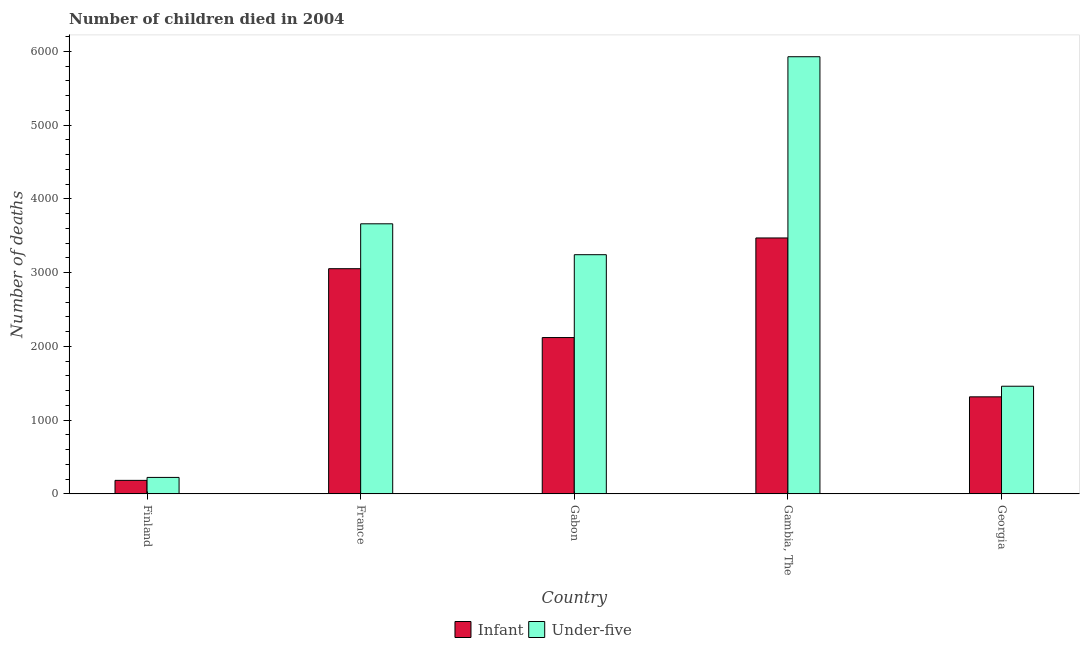How many groups of bars are there?
Provide a succinct answer. 5. Are the number of bars on each tick of the X-axis equal?
Make the answer very short. Yes. How many bars are there on the 2nd tick from the right?
Give a very brief answer. 2. What is the label of the 4th group of bars from the left?
Offer a very short reply. Gambia, The. What is the number of under-five deaths in Georgia?
Ensure brevity in your answer.  1460. Across all countries, what is the maximum number of under-five deaths?
Keep it short and to the point. 5929. Across all countries, what is the minimum number of under-five deaths?
Your answer should be compact. 223. In which country was the number of infant deaths maximum?
Your answer should be compact. Gambia, The. In which country was the number of under-five deaths minimum?
Provide a short and direct response. Finland. What is the total number of under-five deaths in the graph?
Your answer should be compact. 1.45e+04. What is the difference between the number of infant deaths in Finland and that in Gambia, The?
Provide a short and direct response. -3288. What is the difference between the number of infant deaths in Georgia and the number of under-five deaths in France?
Your response must be concise. -2347. What is the average number of under-five deaths per country?
Provide a succinct answer. 2903.8. What is the difference between the number of under-five deaths and number of infant deaths in Georgia?
Ensure brevity in your answer.  144. In how many countries, is the number of infant deaths greater than 1200 ?
Make the answer very short. 4. What is the ratio of the number of under-five deaths in France to that in Georgia?
Keep it short and to the point. 2.51. Is the number of infant deaths in France less than that in Georgia?
Make the answer very short. No. What is the difference between the highest and the second highest number of under-five deaths?
Ensure brevity in your answer.  2266. What is the difference between the highest and the lowest number of infant deaths?
Offer a very short reply. 3288. In how many countries, is the number of under-five deaths greater than the average number of under-five deaths taken over all countries?
Offer a terse response. 3. Is the sum of the number of under-five deaths in France and Georgia greater than the maximum number of infant deaths across all countries?
Offer a terse response. Yes. What does the 1st bar from the left in France represents?
Keep it short and to the point. Infant. What does the 2nd bar from the right in Gambia, The represents?
Ensure brevity in your answer.  Infant. How many countries are there in the graph?
Ensure brevity in your answer.  5. Are the values on the major ticks of Y-axis written in scientific E-notation?
Your answer should be compact. No. Does the graph contain grids?
Offer a very short reply. No. Where does the legend appear in the graph?
Give a very brief answer. Bottom center. How many legend labels are there?
Make the answer very short. 2. How are the legend labels stacked?
Your response must be concise. Horizontal. What is the title of the graph?
Keep it short and to the point. Number of children died in 2004. What is the label or title of the X-axis?
Provide a short and direct response. Country. What is the label or title of the Y-axis?
Offer a terse response. Number of deaths. What is the Number of deaths of Infant in Finland?
Give a very brief answer. 183. What is the Number of deaths of Under-five in Finland?
Provide a succinct answer. 223. What is the Number of deaths in Infant in France?
Your answer should be compact. 3054. What is the Number of deaths of Under-five in France?
Provide a succinct answer. 3663. What is the Number of deaths in Infant in Gabon?
Ensure brevity in your answer.  2120. What is the Number of deaths in Under-five in Gabon?
Provide a succinct answer. 3244. What is the Number of deaths of Infant in Gambia, The?
Provide a succinct answer. 3471. What is the Number of deaths in Under-five in Gambia, The?
Your answer should be compact. 5929. What is the Number of deaths in Infant in Georgia?
Make the answer very short. 1316. What is the Number of deaths in Under-five in Georgia?
Provide a short and direct response. 1460. Across all countries, what is the maximum Number of deaths of Infant?
Keep it short and to the point. 3471. Across all countries, what is the maximum Number of deaths of Under-five?
Keep it short and to the point. 5929. Across all countries, what is the minimum Number of deaths of Infant?
Give a very brief answer. 183. Across all countries, what is the minimum Number of deaths of Under-five?
Offer a terse response. 223. What is the total Number of deaths in Infant in the graph?
Offer a terse response. 1.01e+04. What is the total Number of deaths in Under-five in the graph?
Offer a terse response. 1.45e+04. What is the difference between the Number of deaths in Infant in Finland and that in France?
Offer a very short reply. -2871. What is the difference between the Number of deaths in Under-five in Finland and that in France?
Offer a very short reply. -3440. What is the difference between the Number of deaths of Infant in Finland and that in Gabon?
Provide a succinct answer. -1937. What is the difference between the Number of deaths in Under-five in Finland and that in Gabon?
Provide a short and direct response. -3021. What is the difference between the Number of deaths of Infant in Finland and that in Gambia, The?
Give a very brief answer. -3288. What is the difference between the Number of deaths of Under-five in Finland and that in Gambia, The?
Make the answer very short. -5706. What is the difference between the Number of deaths of Infant in Finland and that in Georgia?
Provide a short and direct response. -1133. What is the difference between the Number of deaths of Under-five in Finland and that in Georgia?
Your answer should be compact. -1237. What is the difference between the Number of deaths of Infant in France and that in Gabon?
Your answer should be compact. 934. What is the difference between the Number of deaths in Under-five in France and that in Gabon?
Keep it short and to the point. 419. What is the difference between the Number of deaths in Infant in France and that in Gambia, The?
Provide a succinct answer. -417. What is the difference between the Number of deaths of Under-five in France and that in Gambia, The?
Keep it short and to the point. -2266. What is the difference between the Number of deaths in Infant in France and that in Georgia?
Offer a very short reply. 1738. What is the difference between the Number of deaths in Under-five in France and that in Georgia?
Give a very brief answer. 2203. What is the difference between the Number of deaths in Infant in Gabon and that in Gambia, The?
Offer a terse response. -1351. What is the difference between the Number of deaths in Under-five in Gabon and that in Gambia, The?
Offer a terse response. -2685. What is the difference between the Number of deaths of Infant in Gabon and that in Georgia?
Ensure brevity in your answer.  804. What is the difference between the Number of deaths in Under-five in Gabon and that in Georgia?
Your answer should be compact. 1784. What is the difference between the Number of deaths of Infant in Gambia, The and that in Georgia?
Provide a succinct answer. 2155. What is the difference between the Number of deaths in Under-five in Gambia, The and that in Georgia?
Your answer should be compact. 4469. What is the difference between the Number of deaths in Infant in Finland and the Number of deaths in Under-five in France?
Your response must be concise. -3480. What is the difference between the Number of deaths in Infant in Finland and the Number of deaths in Under-five in Gabon?
Ensure brevity in your answer.  -3061. What is the difference between the Number of deaths of Infant in Finland and the Number of deaths of Under-five in Gambia, The?
Provide a short and direct response. -5746. What is the difference between the Number of deaths in Infant in Finland and the Number of deaths in Under-five in Georgia?
Offer a terse response. -1277. What is the difference between the Number of deaths in Infant in France and the Number of deaths in Under-five in Gabon?
Your answer should be very brief. -190. What is the difference between the Number of deaths of Infant in France and the Number of deaths of Under-five in Gambia, The?
Your response must be concise. -2875. What is the difference between the Number of deaths of Infant in France and the Number of deaths of Under-five in Georgia?
Make the answer very short. 1594. What is the difference between the Number of deaths of Infant in Gabon and the Number of deaths of Under-five in Gambia, The?
Offer a terse response. -3809. What is the difference between the Number of deaths in Infant in Gabon and the Number of deaths in Under-five in Georgia?
Your response must be concise. 660. What is the difference between the Number of deaths of Infant in Gambia, The and the Number of deaths of Under-five in Georgia?
Provide a short and direct response. 2011. What is the average Number of deaths in Infant per country?
Give a very brief answer. 2028.8. What is the average Number of deaths of Under-five per country?
Your answer should be compact. 2903.8. What is the difference between the Number of deaths of Infant and Number of deaths of Under-five in France?
Provide a succinct answer. -609. What is the difference between the Number of deaths of Infant and Number of deaths of Under-five in Gabon?
Keep it short and to the point. -1124. What is the difference between the Number of deaths of Infant and Number of deaths of Under-five in Gambia, The?
Keep it short and to the point. -2458. What is the difference between the Number of deaths of Infant and Number of deaths of Under-five in Georgia?
Keep it short and to the point. -144. What is the ratio of the Number of deaths in Infant in Finland to that in France?
Provide a short and direct response. 0.06. What is the ratio of the Number of deaths in Under-five in Finland to that in France?
Make the answer very short. 0.06. What is the ratio of the Number of deaths of Infant in Finland to that in Gabon?
Give a very brief answer. 0.09. What is the ratio of the Number of deaths of Under-five in Finland to that in Gabon?
Your answer should be very brief. 0.07. What is the ratio of the Number of deaths in Infant in Finland to that in Gambia, The?
Your answer should be compact. 0.05. What is the ratio of the Number of deaths of Under-five in Finland to that in Gambia, The?
Provide a short and direct response. 0.04. What is the ratio of the Number of deaths in Infant in Finland to that in Georgia?
Your answer should be very brief. 0.14. What is the ratio of the Number of deaths of Under-five in Finland to that in Georgia?
Give a very brief answer. 0.15. What is the ratio of the Number of deaths of Infant in France to that in Gabon?
Give a very brief answer. 1.44. What is the ratio of the Number of deaths in Under-five in France to that in Gabon?
Ensure brevity in your answer.  1.13. What is the ratio of the Number of deaths in Infant in France to that in Gambia, The?
Offer a terse response. 0.88. What is the ratio of the Number of deaths of Under-five in France to that in Gambia, The?
Keep it short and to the point. 0.62. What is the ratio of the Number of deaths in Infant in France to that in Georgia?
Keep it short and to the point. 2.32. What is the ratio of the Number of deaths in Under-five in France to that in Georgia?
Your answer should be very brief. 2.51. What is the ratio of the Number of deaths in Infant in Gabon to that in Gambia, The?
Provide a short and direct response. 0.61. What is the ratio of the Number of deaths of Under-five in Gabon to that in Gambia, The?
Give a very brief answer. 0.55. What is the ratio of the Number of deaths of Infant in Gabon to that in Georgia?
Provide a succinct answer. 1.61. What is the ratio of the Number of deaths in Under-five in Gabon to that in Georgia?
Provide a short and direct response. 2.22. What is the ratio of the Number of deaths in Infant in Gambia, The to that in Georgia?
Offer a terse response. 2.64. What is the ratio of the Number of deaths of Under-five in Gambia, The to that in Georgia?
Make the answer very short. 4.06. What is the difference between the highest and the second highest Number of deaths in Infant?
Give a very brief answer. 417. What is the difference between the highest and the second highest Number of deaths of Under-five?
Offer a terse response. 2266. What is the difference between the highest and the lowest Number of deaths of Infant?
Your answer should be compact. 3288. What is the difference between the highest and the lowest Number of deaths in Under-five?
Keep it short and to the point. 5706. 